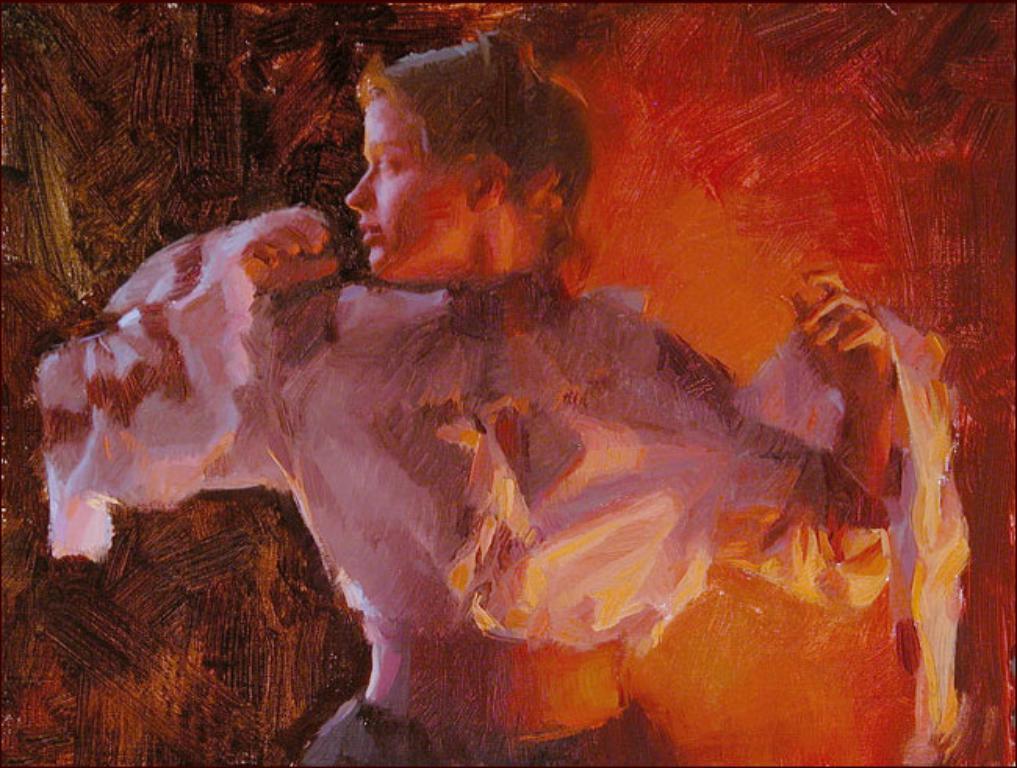Please provide a concise description of this image. In this image we can see a painting of a woman. 